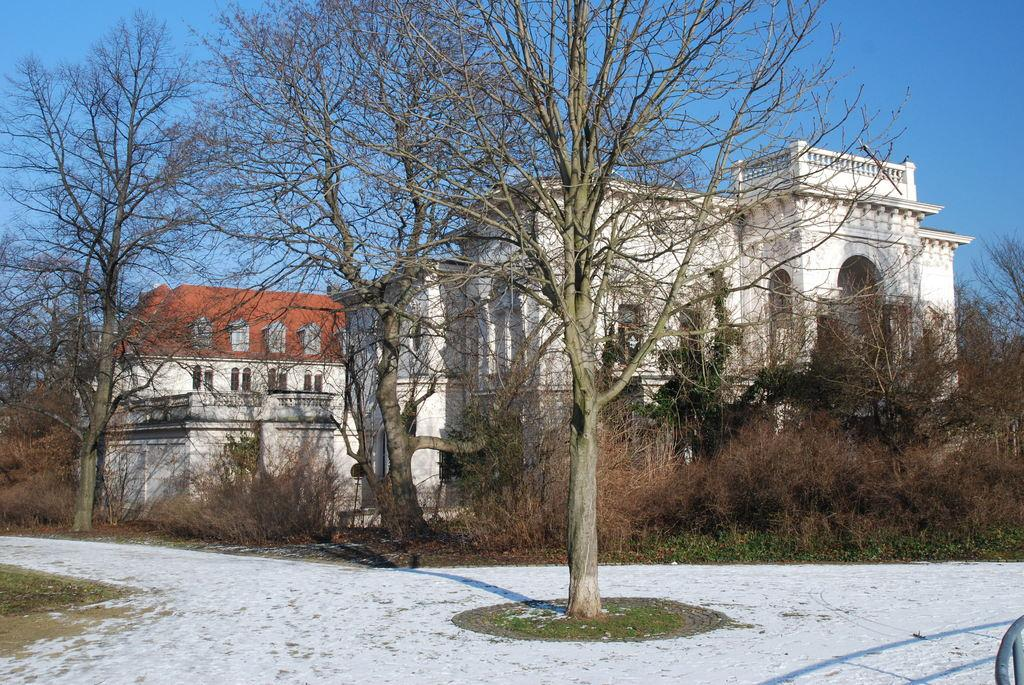What type of trees can be seen in the foreground of the picture? There are deciduous trees in the foreground of the picture. What is the ground covered with at the bottom of the picture? There is snow at the bottom of the picture. What can be seen in the distance in the background of the picture? There are buildings visible in the background of the picture. How many beginner drivers are visible in the picture? There is no information about cars or drivers in the image, so it is impossible to determine the number of beginner drivers. What type of harmony is present in the picture? The concept of harmony is not applicable to the image, as it is a visual representation of a scene and does not convey emotions or musical qualities. 